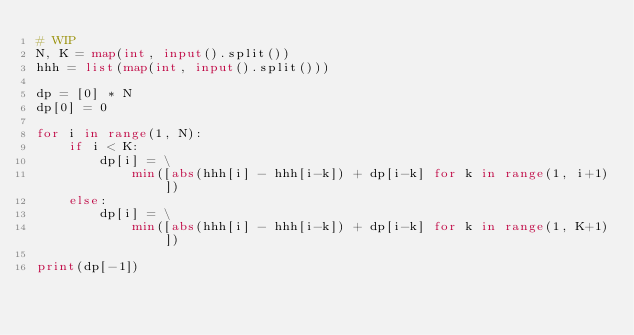Convert code to text. <code><loc_0><loc_0><loc_500><loc_500><_Python_># WIP
N, K = map(int, input().split())
hhh = list(map(int, input().split()))

dp = [0] * N
dp[0] = 0

for i in range(1, N):
    if i < K:
        dp[i] = \
            min([abs(hhh[i] - hhh[i-k]) + dp[i-k] for k in range(1, i+1)])
    else:
        dp[i] = \
            min([abs(hhh[i] - hhh[i-k]) + dp[i-k] for k in range(1, K+1)])

print(dp[-1])
</code> 